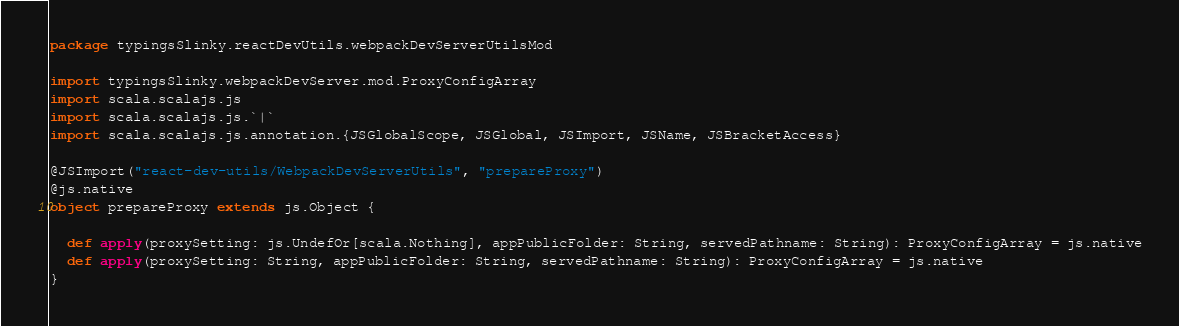Convert code to text. <code><loc_0><loc_0><loc_500><loc_500><_Scala_>package typingsSlinky.reactDevUtils.webpackDevServerUtilsMod

import typingsSlinky.webpackDevServer.mod.ProxyConfigArray
import scala.scalajs.js
import scala.scalajs.js.`|`
import scala.scalajs.js.annotation.{JSGlobalScope, JSGlobal, JSImport, JSName, JSBracketAccess}

@JSImport("react-dev-utils/WebpackDevServerUtils", "prepareProxy")
@js.native
object prepareProxy extends js.Object {
  
  def apply(proxySetting: js.UndefOr[scala.Nothing], appPublicFolder: String, servedPathname: String): ProxyConfigArray = js.native
  def apply(proxySetting: String, appPublicFolder: String, servedPathname: String): ProxyConfigArray = js.native
}
</code> 